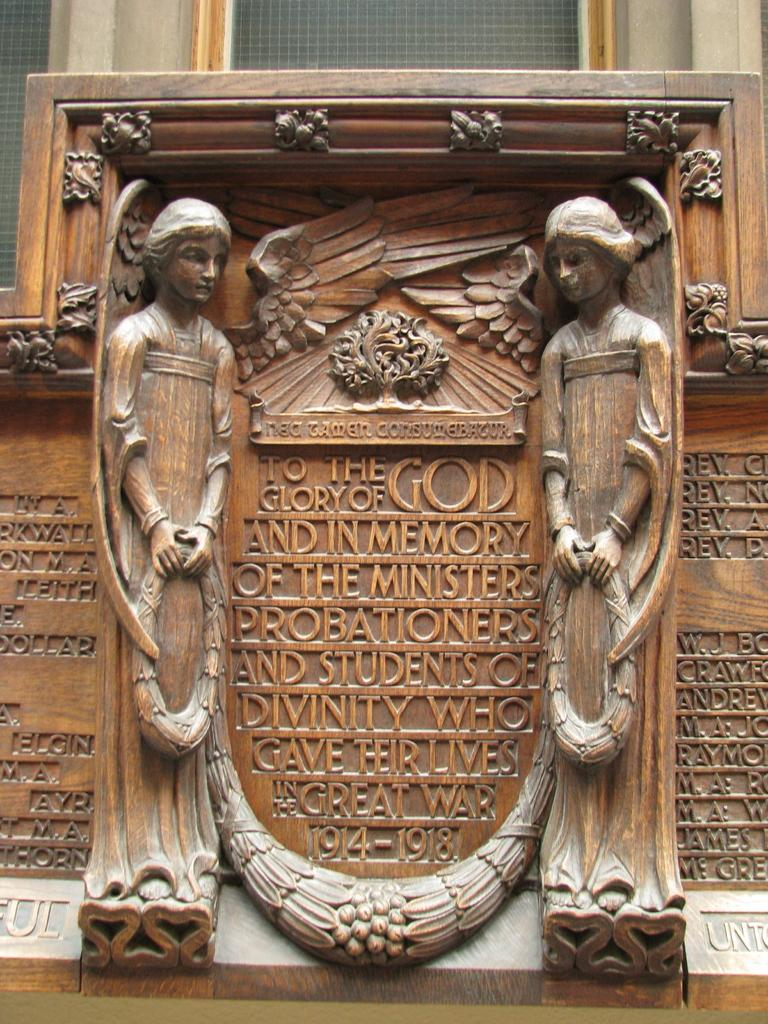What type of material is used to create the sculptures in the image? The sculptures in the image are made of wood. What can be seen in the background of the image? There are windows and a wall in the background of the image. Is there a bear in the image that is involved in a trade with the wooden sculptures? No, there is no bear or trade present in the image. The image only features wooden sculptures and a background with windows and a wall. 